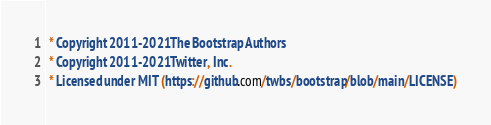<code> <loc_0><loc_0><loc_500><loc_500><_CSS_> * Copyright 2011-2021 The Bootstrap Authors
 * Copyright 2011-2021 Twitter, Inc.
 * Licensed under MIT (https://github.com/twbs/bootstrap/blob/main/LICENSE)</code> 